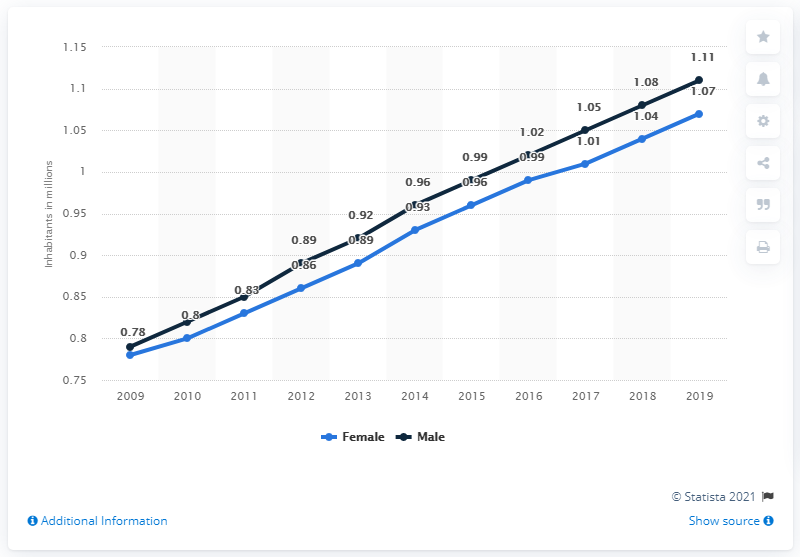Identify some key points in this picture. In 2019, the male population of Gabon was 1.11 million. In 2019, the female population of Gabon was estimated to be 1.07 million. 